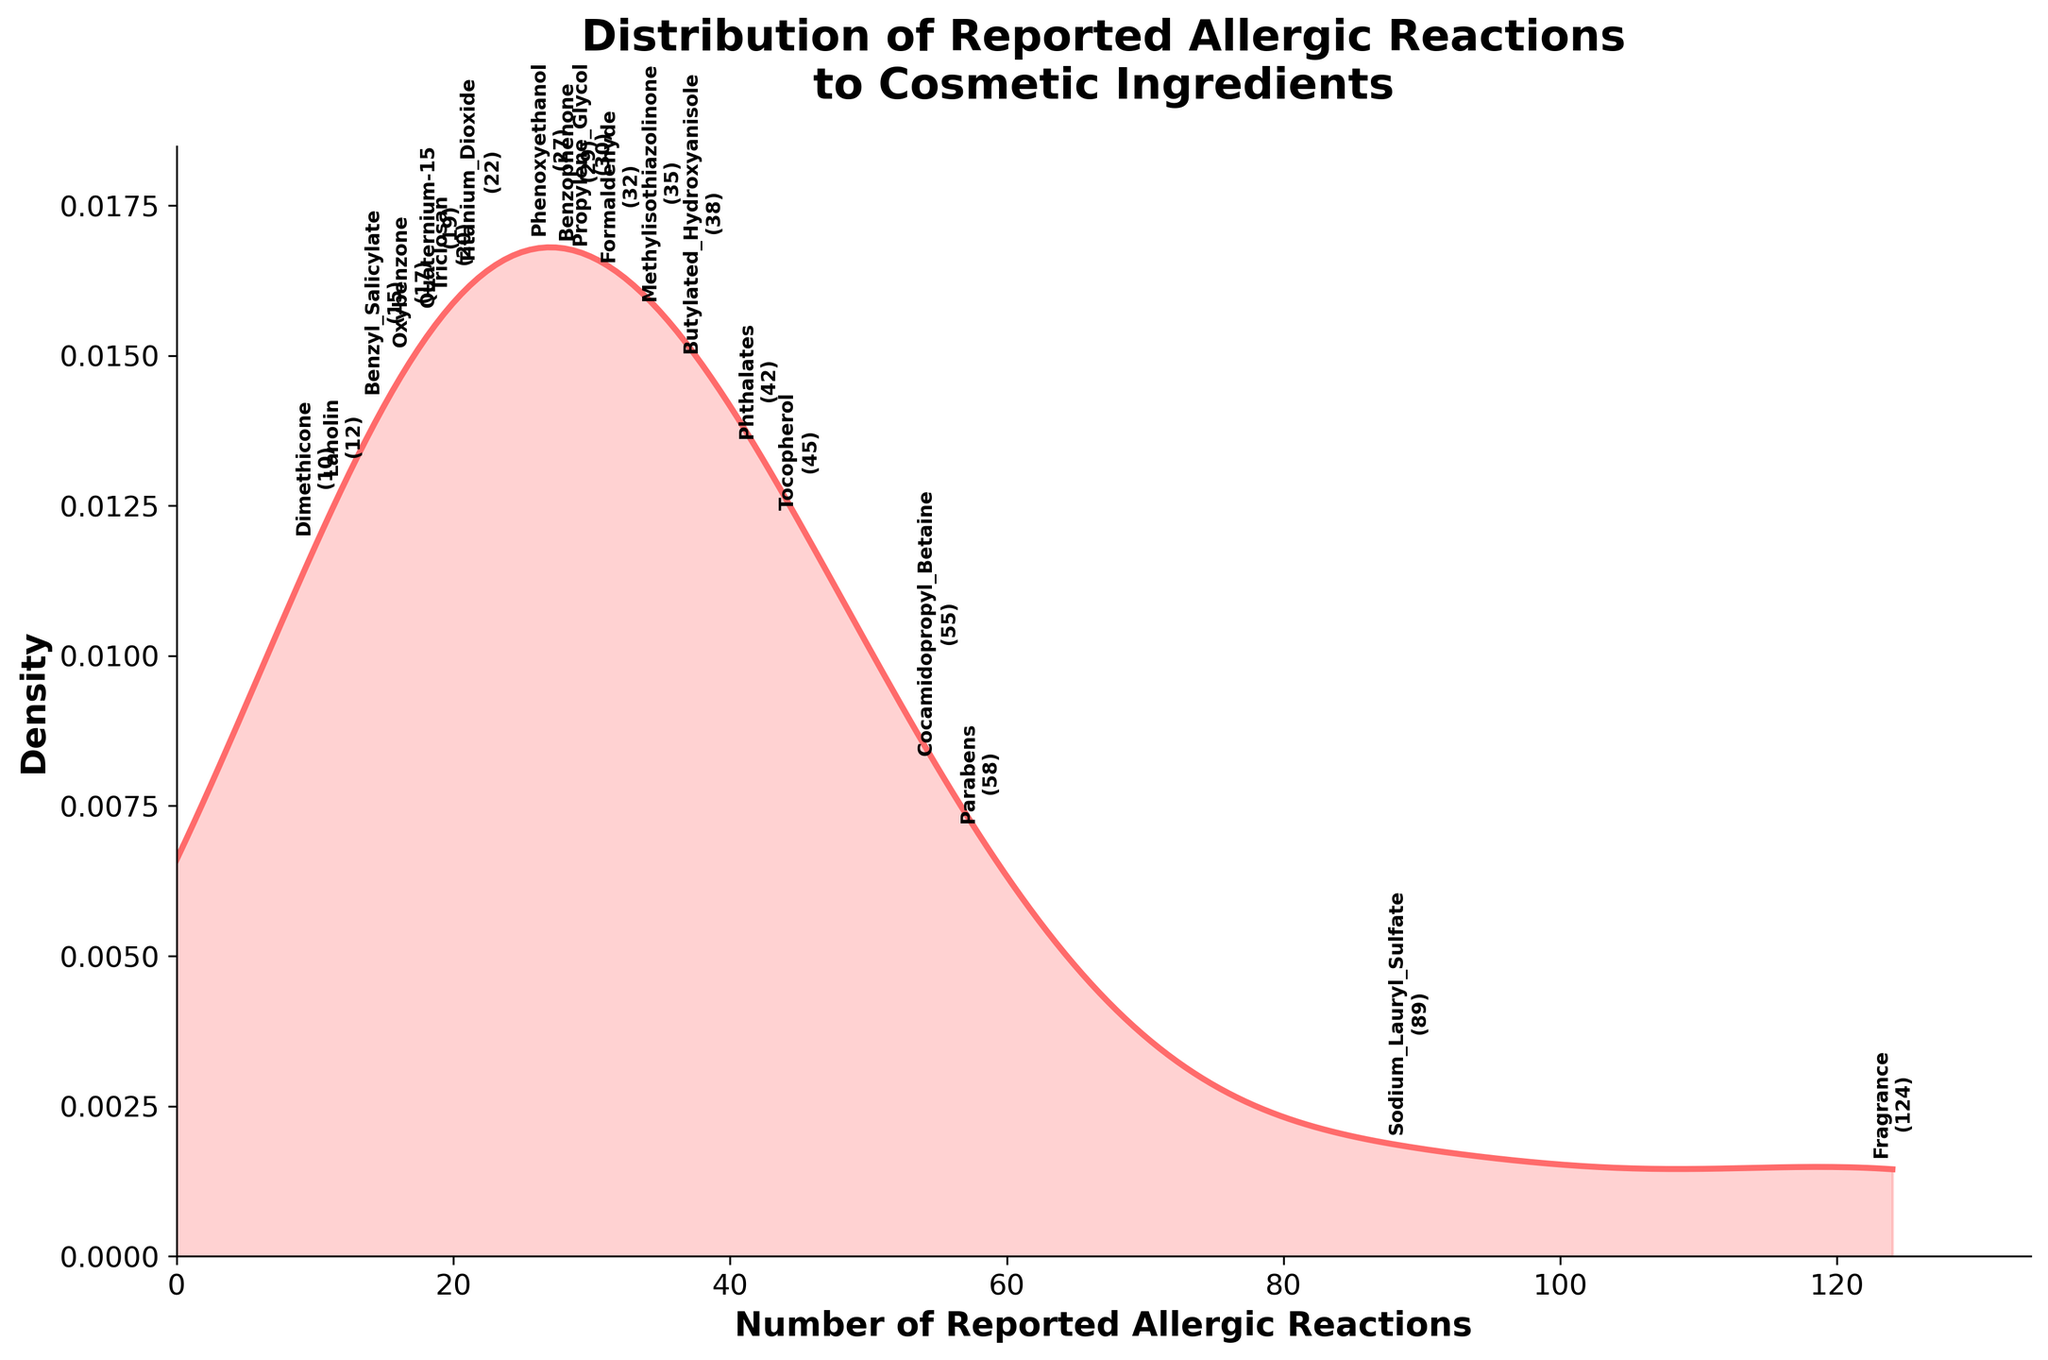What is the title of the figure? The title is displayed at the top of the figure, above the plot area. It usually provides a concise description of what the figure is about.
Answer: Distribution of Reported Allergic Reactions to Cosmetic Ingredients Which ingredient has the highest number of reported allergic reactions? Look at the annotations corresponding to the highest density peak on the x-axis. The label indicating the ingredient with the highest number of reactions should be clearly visible.
Answer: Fragrance How many reported allergic reactions are there for Sodium Lauryl Sulfate? Sodium Lauryl Sulfate is one of the labeled ingredients on the plot's x-axis. Locate its annotated label and note the number of reported reactions.
Answer: 89 What is the approximate density value for Benzophenone at its reported allergic reactions? Find the annotated label for Benzophenone on the x-axis and observe its corresponding point on the density curve. Approximate the y-axis value at this point.
Answer: Approx. 0.015 Compare the reported allergic reactions for Cocamidopropyl Betaine and Benzyl Salicylate. By how many do they differ? Locate the annotated labels for Cocamidopropyl Betaine and Benzyl Salicylate on the x-axis, read their respective numbers (55 and 15), and find the difference.
Answer: 40 Which ingredients have less than 20 reported allergic reactions? Identify the ingredients with annotations positioned at an x-axis value below 20. This includes Lanolin (12), Oxybenzone (17), Dimethicone (10), Benzyl Salicylate (15), and Quaternium-15 (19).
Answer: Lanolin, Oxybenzone, Dimethicone, Benzyl Salicylate, Quaternium-15 What is the shape of the density curve? Observe the general pattern of the density curve. Describe whether it has multiple peaks, a single peak, or is flat, etc.
Answer: Single peak with a long tail to the right Which ingredient is closest to the median number of reported allergic reactions? Determine the median number of reported reactions by finding the middle value in an ordered list of reactions. Identify the ingredient whose annotated label corresponds to this value.
Answer: Tocopherol By how much does the number of reported allergic reactions for Parabens exceed that for Dimethicone? Locate the annotations for Parabens and Dimethicone, find their respective numbers (58 and 10), and subtract the latter from the former.
Answer: 48 